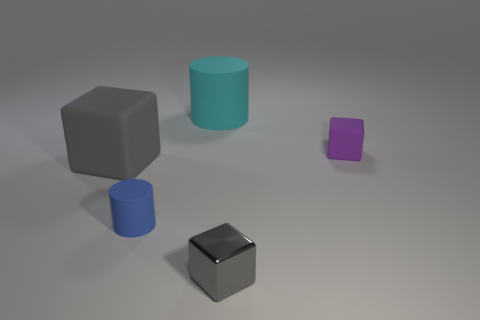There is a gray block that is on the right side of the tiny rubber cylinder; what is it made of?
Your answer should be compact. Metal. The big cube that is made of the same material as the purple object is what color?
Provide a succinct answer. Gray. Does the big cyan matte thing have the same shape as the big object on the left side of the big cyan matte cylinder?
Your answer should be compact. No. Are there any purple objects in front of the cyan cylinder?
Give a very brief answer. Yes. There is a large thing that is the same color as the tiny shiny thing; what material is it?
Ensure brevity in your answer.  Rubber. Is the size of the gray rubber thing the same as the gray object that is on the right side of the big cyan rubber cylinder?
Offer a terse response. No. Are there any other large cubes that have the same color as the big rubber block?
Give a very brief answer. No. Is there a big red matte object of the same shape as the large cyan thing?
Your response must be concise. No. What is the shape of the small object that is both right of the big cyan matte cylinder and behind the tiny gray metal cube?
Ensure brevity in your answer.  Cube. How many cyan cylinders have the same material as the cyan thing?
Your answer should be very brief. 0. 